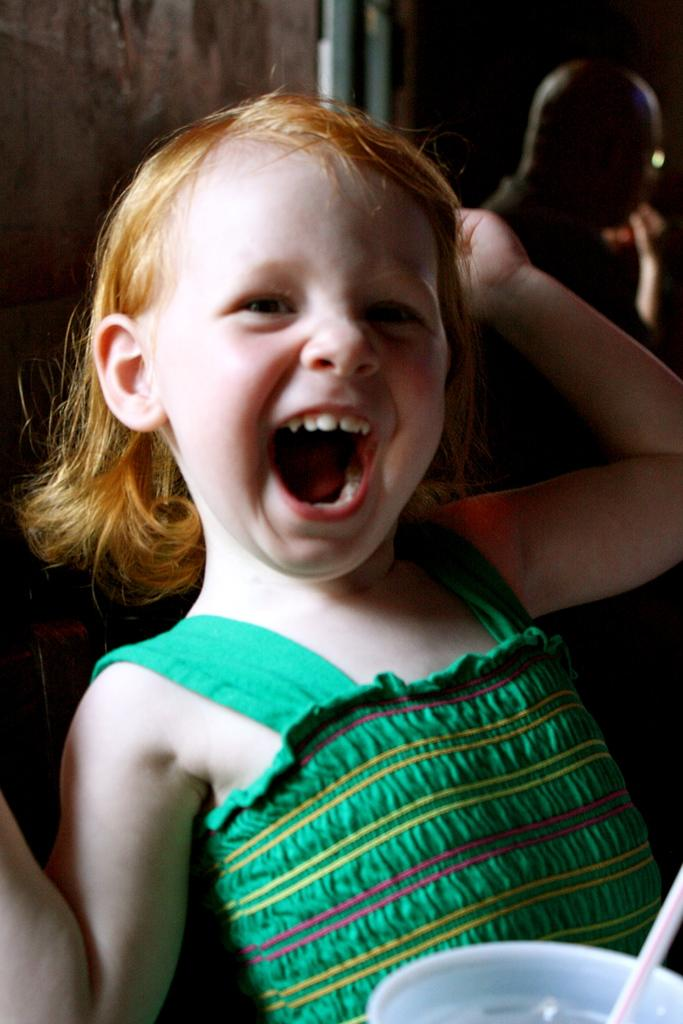Who is the main subject in the image? There is a small girl in the image. What is the girl doing in the image? The girl is smiling in the image. Can you describe the background of the image? There is a person in the background of the image. How many oranges are on the bridge in the image? There is no bridge or oranges present in the image. What is the girl's reaction to the surprise in the image? There is no surprise mentioned or depicted in the image. 